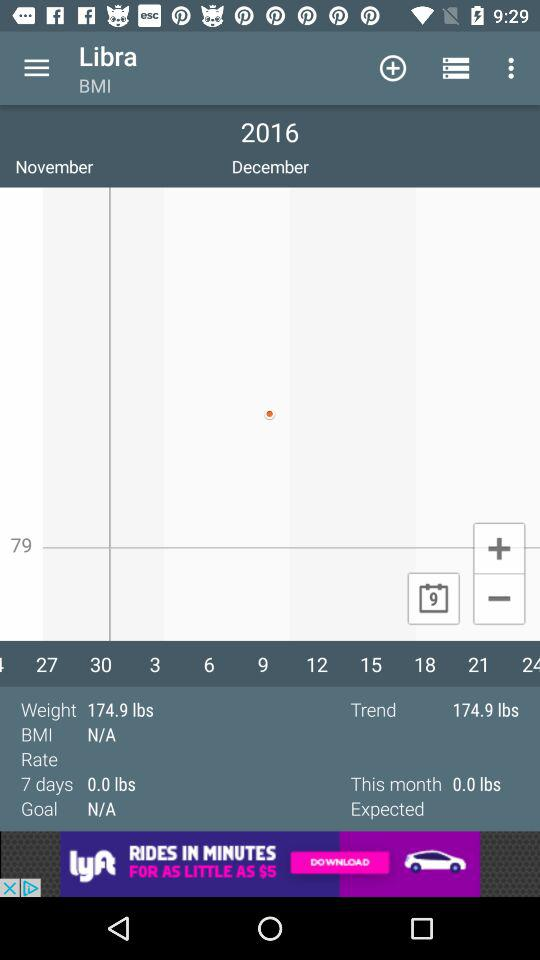What is the difference between the expected and actual weight for this month?
Answer the question using a single word or phrase. 0.0 lbs 